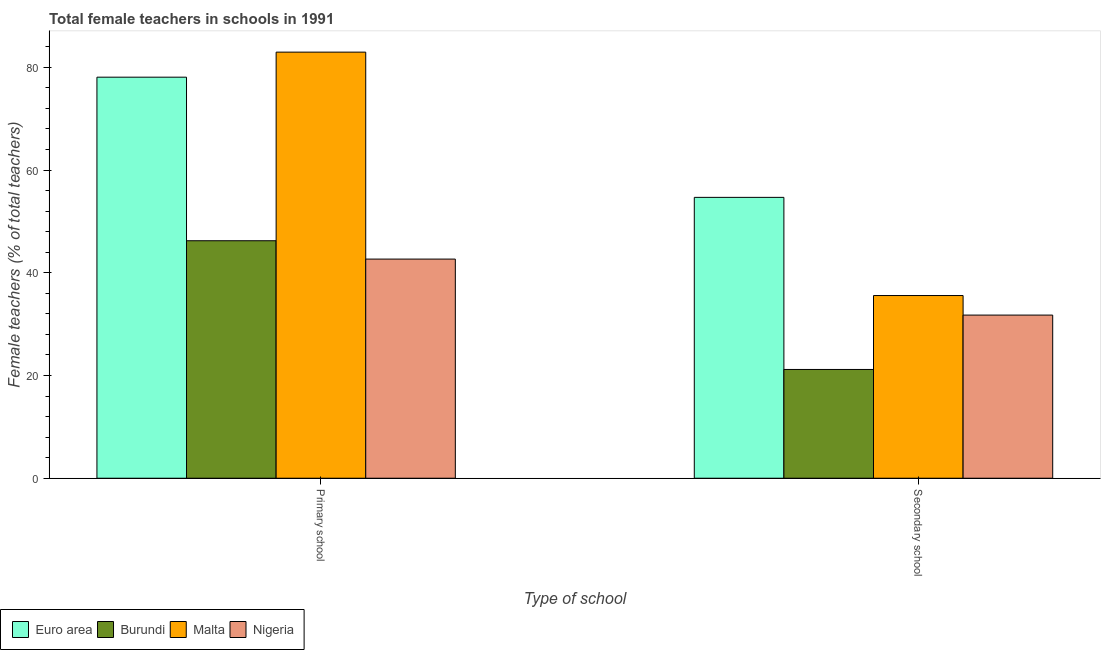How many groups of bars are there?
Offer a very short reply. 2. How many bars are there on the 1st tick from the left?
Offer a terse response. 4. How many bars are there on the 2nd tick from the right?
Make the answer very short. 4. What is the label of the 2nd group of bars from the left?
Keep it short and to the point. Secondary school. What is the percentage of female teachers in primary schools in Nigeria?
Offer a terse response. 42.66. Across all countries, what is the maximum percentage of female teachers in secondary schools?
Provide a succinct answer. 54.67. Across all countries, what is the minimum percentage of female teachers in primary schools?
Offer a terse response. 42.66. In which country was the percentage of female teachers in primary schools maximum?
Your response must be concise. Malta. In which country was the percentage of female teachers in primary schools minimum?
Keep it short and to the point. Nigeria. What is the total percentage of female teachers in primary schools in the graph?
Your answer should be compact. 249.92. What is the difference between the percentage of female teachers in primary schools in Euro area and that in Malta?
Keep it short and to the point. -4.88. What is the difference between the percentage of female teachers in secondary schools in Burundi and the percentage of female teachers in primary schools in Malta?
Your response must be concise. -61.77. What is the average percentage of female teachers in secondary schools per country?
Your answer should be compact. 35.79. What is the difference between the percentage of female teachers in secondary schools and percentage of female teachers in primary schools in Burundi?
Provide a succinct answer. -25.06. In how many countries, is the percentage of female teachers in primary schools greater than 36 %?
Your response must be concise. 4. What is the ratio of the percentage of female teachers in primary schools in Euro area to that in Nigeria?
Provide a short and direct response. 1.83. Is the percentage of female teachers in secondary schools in Euro area less than that in Nigeria?
Provide a short and direct response. No. In how many countries, is the percentage of female teachers in primary schools greater than the average percentage of female teachers in primary schools taken over all countries?
Provide a succinct answer. 2. What does the 1st bar from the left in Secondary school represents?
Your answer should be compact. Euro area. What does the 1st bar from the right in Secondary school represents?
Ensure brevity in your answer.  Nigeria. How many bars are there?
Your response must be concise. 8. Are all the bars in the graph horizontal?
Your answer should be very brief. No. How many countries are there in the graph?
Provide a short and direct response. 4. What is the difference between two consecutive major ticks on the Y-axis?
Make the answer very short. 20. Does the graph contain grids?
Your answer should be very brief. No. Where does the legend appear in the graph?
Keep it short and to the point. Bottom left. How many legend labels are there?
Your response must be concise. 4. What is the title of the graph?
Your answer should be very brief. Total female teachers in schools in 1991. Does "Guyana" appear as one of the legend labels in the graph?
Ensure brevity in your answer.  No. What is the label or title of the X-axis?
Offer a terse response. Type of school. What is the label or title of the Y-axis?
Provide a succinct answer. Female teachers (% of total teachers). What is the Female teachers (% of total teachers) of Euro area in Primary school?
Offer a terse response. 78.07. What is the Female teachers (% of total teachers) in Burundi in Primary school?
Your response must be concise. 46.23. What is the Female teachers (% of total teachers) of Malta in Primary school?
Provide a succinct answer. 82.95. What is the Female teachers (% of total teachers) of Nigeria in Primary school?
Offer a terse response. 42.66. What is the Female teachers (% of total teachers) of Euro area in Secondary school?
Offer a very short reply. 54.67. What is the Female teachers (% of total teachers) in Burundi in Secondary school?
Keep it short and to the point. 21.17. What is the Female teachers (% of total teachers) of Malta in Secondary school?
Make the answer very short. 35.57. What is the Female teachers (% of total teachers) of Nigeria in Secondary school?
Offer a terse response. 31.76. Across all Type of school, what is the maximum Female teachers (% of total teachers) in Euro area?
Give a very brief answer. 78.07. Across all Type of school, what is the maximum Female teachers (% of total teachers) in Burundi?
Provide a short and direct response. 46.23. Across all Type of school, what is the maximum Female teachers (% of total teachers) of Malta?
Provide a short and direct response. 82.95. Across all Type of school, what is the maximum Female teachers (% of total teachers) in Nigeria?
Your answer should be compact. 42.66. Across all Type of school, what is the minimum Female teachers (% of total teachers) of Euro area?
Give a very brief answer. 54.67. Across all Type of school, what is the minimum Female teachers (% of total teachers) in Burundi?
Offer a very short reply. 21.17. Across all Type of school, what is the minimum Female teachers (% of total teachers) of Malta?
Provide a short and direct response. 35.57. Across all Type of school, what is the minimum Female teachers (% of total teachers) of Nigeria?
Ensure brevity in your answer.  31.76. What is the total Female teachers (% of total teachers) of Euro area in the graph?
Provide a succinct answer. 132.75. What is the total Female teachers (% of total teachers) in Burundi in the graph?
Provide a succinct answer. 67.41. What is the total Female teachers (% of total teachers) in Malta in the graph?
Provide a succinct answer. 118.52. What is the total Female teachers (% of total teachers) in Nigeria in the graph?
Ensure brevity in your answer.  74.42. What is the difference between the Female teachers (% of total teachers) in Euro area in Primary school and that in Secondary school?
Keep it short and to the point. 23.4. What is the difference between the Female teachers (% of total teachers) in Burundi in Primary school and that in Secondary school?
Make the answer very short. 25.06. What is the difference between the Female teachers (% of total teachers) in Malta in Primary school and that in Secondary school?
Give a very brief answer. 47.38. What is the difference between the Female teachers (% of total teachers) in Nigeria in Primary school and that in Secondary school?
Ensure brevity in your answer.  10.9. What is the difference between the Female teachers (% of total teachers) of Euro area in Primary school and the Female teachers (% of total teachers) of Burundi in Secondary school?
Provide a succinct answer. 56.9. What is the difference between the Female teachers (% of total teachers) of Euro area in Primary school and the Female teachers (% of total teachers) of Malta in Secondary school?
Keep it short and to the point. 42.51. What is the difference between the Female teachers (% of total teachers) in Euro area in Primary school and the Female teachers (% of total teachers) in Nigeria in Secondary school?
Your response must be concise. 46.32. What is the difference between the Female teachers (% of total teachers) in Burundi in Primary school and the Female teachers (% of total teachers) in Malta in Secondary school?
Provide a short and direct response. 10.67. What is the difference between the Female teachers (% of total teachers) of Burundi in Primary school and the Female teachers (% of total teachers) of Nigeria in Secondary school?
Your response must be concise. 14.47. What is the difference between the Female teachers (% of total teachers) of Malta in Primary school and the Female teachers (% of total teachers) of Nigeria in Secondary school?
Provide a short and direct response. 51.19. What is the average Female teachers (% of total teachers) in Euro area per Type of school?
Your answer should be very brief. 66.37. What is the average Female teachers (% of total teachers) of Burundi per Type of school?
Keep it short and to the point. 33.7. What is the average Female teachers (% of total teachers) of Malta per Type of school?
Offer a terse response. 59.26. What is the average Female teachers (% of total teachers) in Nigeria per Type of school?
Your answer should be compact. 37.21. What is the difference between the Female teachers (% of total teachers) in Euro area and Female teachers (% of total teachers) in Burundi in Primary school?
Your answer should be very brief. 31.84. What is the difference between the Female teachers (% of total teachers) of Euro area and Female teachers (% of total teachers) of Malta in Primary school?
Provide a short and direct response. -4.88. What is the difference between the Female teachers (% of total teachers) of Euro area and Female teachers (% of total teachers) of Nigeria in Primary school?
Provide a succinct answer. 35.41. What is the difference between the Female teachers (% of total teachers) in Burundi and Female teachers (% of total teachers) in Malta in Primary school?
Your answer should be very brief. -36.72. What is the difference between the Female teachers (% of total teachers) of Burundi and Female teachers (% of total teachers) of Nigeria in Primary school?
Provide a short and direct response. 3.57. What is the difference between the Female teachers (% of total teachers) in Malta and Female teachers (% of total teachers) in Nigeria in Primary school?
Your answer should be very brief. 40.29. What is the difference between the Female teachers (% of total teachers) in Euro area and Female teachers (% of total teachers) in Burundi in Secondary school?
Offer a terse response. 33.5. What is the difference between the Female teachers (% of total teachers) in Euro area and Female teachers (% of total teachers) in Malta in Secondary school?
Keep it short and to the point. 19.11. What is the difference between the Female teachers (% of total teachers) in Euro area and Female teachers (% of total teachers) in Nigeria in Secondary school?
Offer a very short reply. 22.92. What is the difference between the Female teachers (% of total teachers) in Burundi and Female teachers (% of total teachers) in Malta in Secondary school?
Give a very brief answer. -14.39. What is the difference between the Female teachers (% of total teachers) of Burundi and Female teachers (% of total teachers) of Nigeria in Secondary school?
Offer a terse response. -10.58. What is the difference between the Female teachers (% of total teachers) of Malta and Female teachers (% of total teachers) of Nigeria in Secondary school?
Offer a very short reply. 3.81. What is the ratio of the Female teachers (% of total teachers) of Euro area in Primary school to that in Secondary school?
Keep it short and to the point. 1.43. What is the ratio of the Female teachers (% of total teachers) of Burundi in Primary school to that in Secondary school?
Your answer should be very brief. 2.18. What is the ratio of the Female teachers (% of total teachers) of Malta in Primary school to that in Secondary school?
Provide a short and direct response. 2.33. What is the ratio of the Female teachers (% of total teachers) of Nigeria in Primary school to that in Secondary school?
Ensure brevity in your answer.  1.34. What is the difference between the highest and the second highest Female teachers (% of total teachers) of Euro area?
Your answer should be very brief. 23.4. What is the difference between the highest and the second highest Female teachers (% of total teachers) in Burundi?
Provide a short and direct response. 25.06. What is the difference between the highest and the second highest Female teachers (% of total teachers) of Malta?
Your answer should be very brief. 47.38. What is the difference between the highest and the second highest Female teachers (% of total teachers) of Nigeria?
Provide a succinct answer. 10.9. What is the difference between the highest and the lowest Female teachers (% of total teachers) of Euro area?
Make the answer very short. 23.4. What is the difference between the highest and the lowest Female teachers (% of total teachers) of Burundi?
Keep it short and to the point. 25.06. What is the difference between the highest and the lowest Female teachers (% of total teachers) in Malta?
Ensure brevity in your answer.  47.38. What is the difference between the highest and the lowest Female teachers (% of total teachers) in Nigeria?
Your answer should be very brief. 10.9. 